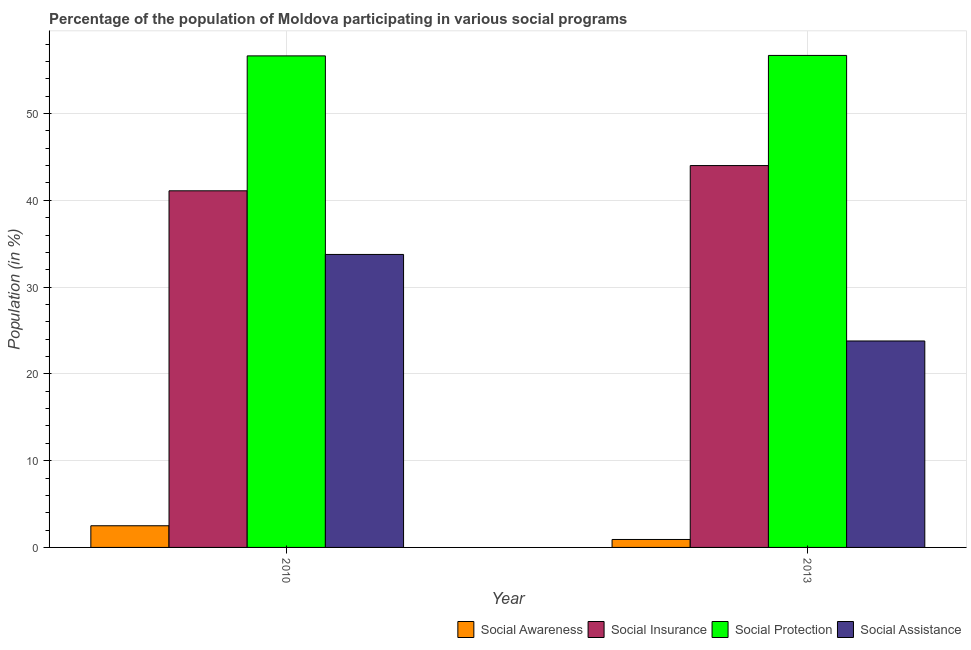How many different coloured bars are there?
Make the answer very short. 4. Are the number of bars per tick equal to the number of legend labels?
Provide a short and direct response. Yes. How many bars are there on the 2nd tick from the left?
Your answer should be compact. 4. What is the label of the 2nd group of bars from the left?
Provide a succinct answer. 2013. What is the participation of population in social protection programs in 2013?
Your answer should be compact. 56.7. Across all years, what is the maximum participation of population in social awareness programs?
Keep it short and to the point. 2.5. Across all years, what is the minimum participation of population in social protection programs?
Keep it short and to the point. 56.65. In which year was the participation of population in social insurance programs maximum?
Offer a terse response. 2013. In which year was the participation of population in social protection programs minimum?
Make the answer very short. 2010. What is the total participation of population in social awareness programs in the graph?
Your response must be concise. 3.41. What is the difference between the participation of population in social awareness programs in 2010 and that in 2013?
Your answer should be compact. 1.58. What is the difference between the participation of population in social protection programs in 2010 and the participation of population in social insurance programs in 2013?
Your response must be concise. -0.05. What is the average participation of population in social protection programs per year?
Your answer should be compact. 56.67. In the year 2013, what is the difference between the participation of population in social protection programs and participation of population in social awareness programs?
Keep it short and to the point. 0. In how many years, is the participation of population in social protection programs greater than 26 %?
Offer a very short reply. 2. What is the ratio of the participation of population in social protection programs in 2010 to that in 2013?
Your answer should be very brief. 1. In how many years, is the participation of population in social assistance programs greater than the average participation of population in social assistance programs taken over all years?
Your answer should be very brief. 1. Is it the case that in every year, the sum of the participation of population in social protection programs and participation of population in social awareness programs is greater than the sum of participation of population in social assistance programs and participation of population in social insurance programs?
Keep it short and to the point. Yes. What does the 2nd bar from the left in 2010 represents?
Provide a succinct answer. Social Insurance. What does the 2nd bar from the right in 2010 represents?
Provide a short and direct response. Social Protection. Are all the bars in the graph horizontal?
Your answer should be very brief. No. How many years are there in the graph?
Your answer should be very brief. 2. Are the values on the major ticks of Y-axis written in scientific E-notation?
Keep it short and to the point. No. Does the graph contain any zero values?
Offer a terse response. No. Where does the legend appear in the graph?
Provide a short and direct response. Bottom right. How are the legend labels stacked?
Provide a short and direct response. Horizontal. What is the title of the graph?
Your answer should be very brief. Percentage of the population of Moldova participating in various social programs . What is the label or title of the Y-axis?
Offer a terse response. Population (in %). What is the Population (in %) in Social Awareness in 2010?
Your answer should be compact. 2.5. What is the Population (in %) of Social Insurance in 2010?
Your answer should be very brief. 41.1. What is the Population (in %) in Social Protection in 2010?
Your answer should be very brief. 56.65. What is the Population (in %) of Social Assistance in 2010?
Your answer should be compact. 33.76. What is the Population (in %) in Social Awareness in 2013?
Provide a succinct answer. 0.92. What is the Population (in %) of Social Insurance in 2013?
Make the answer very short. 44.01. What is the Population (in %) in Social Protection in 2013?
Your answer should be compact. 56.7. What is the Population (in %) in Social Assistance in 2013?
Make the answer very short. 23.79. Across all years, what is the maximum Population (in %) of Social Awareness?
Offer a very short reply. 2.5. Across all years, what is the maximum Population (in %) in Social Insurance?
Your answer should be very brief. 44.01. Across all years, what is the maximum Population (in %) in Social Protection?
Your response must be concise. 56.7. Across all years, what is the maximum Population (in %) of Social Assistance?
Offer a terse response. 33.76. Across all years, what is the minimum Population (in %) of Social Awareness?
Provide a short and direct response. 0.92. Across all years, what is the minimum Population (in %) of Social Insurance?
Offer a very short reply. 41.1. Across all years, what is the minimum Population (in %) of Social Protection?
Give a very brief answer. 56.65. Across all years, what is the minimum Population (in %) of Social Assistance?
Your answer should be compact. 23.79. What is the total Population (in %) of Social Awareness in the graph?
Offer a very short reply. 3.41. What is the total Population (in %) of Social Insurance in the graph?
Give a very brief answer. 85.1. What is the total Population (in %) of Social Protection in the graph?
Your response must be concise. 113.35. What is the total Population (in %) in Social Assistance in the graph?
Your answer should be compact. 57.56. What is the difference between the Population (in %) in Social Awareness in 2010 and that in 2013?
Offer a terse response. 1.58. What is the difference between the Population (in %) of Social Insurance in 2010 and that in 2013?
Provide a succinct answer. -2.91. What is the difference between the Population (in %) in Social Protection in 2010 and that in 2013?
Your response must be concise. -0.05. What is the difference between the Population (in %) of Social Assistance in 2010 and that in 2013?
Make the answer very short. 9.97. What is the difference between the Population (in %) in Social Awareness in 2010 and the Population (in %) in Social Insurance in 2013?
Provide a short and direct response. -41.51. What is the difference between the Population (in %) in Social Awareness in 2010 and the Population (in %) in Social Protection in 2013?
Provide a short and direct response. -54.2. What is the difference between the Population (in %) in Social Awareness in 2010 and the Population (in %) in Social Assistance in 2013?
Your response must be concise. -21.3. What is the difference between the Population (in %) in Social Insurance in 2010 and the Population (in %) in Social Protection in 2013?
Offer a terse response. -15.6. What is the difference between the Population (in %) of Social Insurance in 2010 and the Population (in %) of Social Assistance in 2013?
Offer a terse response. 17.31. What is the difference between the Population (in %) of Social Protection in 2010 and the Population (in %) of Social Assistance in 2013?
Your response must be concise. 32.85. What is the average Population (in %) in Social Awareness per year?
Keep it short and to the point. 1.71. What is the average Population (in %) of Social Insurance per year?
Offer a terse response. 42.55. What is the average Population (in %) of Social Protection per year?
Keep it short and to the point. 56.67. What is the average Population (in %) in Social Assistance per year?
Offer a terse response. 28.78. In the year 2010, what is the difference between the Population (in %) in Social Awareness and Population (in %) in Social Insurance?
Offer a very short reply. -38.6. In the year 2010, what is the difference between the Population (in %) of Social Awareness and Population (in %) of Social Protection?
Provide a short and direct response. -54.15. In the year 2010, what is the difference between the Population (in %) of Social Awareness and Population (in %) of Social Assistance?
Provide a succinct answer. -31.27. In the year 2010, what is the difference between the Population (in %) in Social Insurance and Population (in %) in Social Protection?
Provide a succinct answer. -15.55. In the year 2010, what is the difference between the Population (in %) in Social Insurance and Population (in %) in Social Assistance?
Your response must be concise. 7.33. In the year 2010, what is the difference between the Population (in %) in Social Protection and Population (in %) in Social Assistance?
Keep it short and to the point. 22.88. In the year 2013, what is the difference between the Population (in %) of Social Awareness and Population (in %) of Social Insurance?
Provide a succinct answer. -43.09. In the year 2013, what is the difference between the Population (in %) in Social Awareness and Population (in %) in Social Protection?
Provide a succinct answer. -55.78. In the year 2013, what is the difference between the Population (in %) of Social Awareness and Population (in %) of Social Assistance?
Give a very brief answer. -22.88. In the year 2013, what is the difference between the Population (in %) in Social Insurance and Population (in %) in Social Protection?
Your response must be concise. -12.69. In the year 2013, what is the difference between the Population (in %) in Social Insurance and Population (in %) in Social Assistance?
Provide a succinct answer. 20.21. In the year 2013, what is the difference between the Population (in %) in Social Protection and Population (in %) in Social Assistance?
Your response must be concise. 32.91. What is the ratio of the Population (in %) of Social Awareness in 2010 to that in 2013?
Give a very brief answer. 2.73. What is the ratio of the Population (in %) in Social Insurance in 2010 to that in 2013?
Your response must be concise. 0.93. What is the ratio of the Population (in %) of Social Assistance in 2010 to that in 2013?
Ensure brevity in your answer.  1.42. What is the difference between the highest and the second highest Population (in %) in Social Awareness?
Offer a terse response. 1.58. What is the difference between the highest and the second highest Population (in %) of Social Insurance?
Provide a short and direct response. 2.91. What is the difference between the highest and the second highest Population (in %) of Social Protection?
Provide a short and direct response. 0.05. What is the difference between the highest and the second highest Population (in %) of Social Assistance?
Ensure brevity in your answer.  9.97. What is the difference between the highest and the lowest Population (in %) in Social Awareness?
Your answer should be very brief. 1.58. What is the difference between the highest and the lowest Population (in %) in Social Insurance?
Offer a very short reply. 2.91. What is the difference between the highest and the lowest Population (in %) of Social Protection?
Give a very brief answer. 0.05. What is the difference between the highest and the lowest Population (in %) in Social Assistance?
Offer a very short reply. 9.97. 